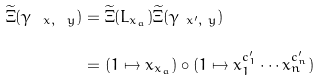Convert formula to latex. <formula><loc_0><loc_0><loc_500><loc_500>\widetilde { \Xi } ( \gamma _ { \ x , \ y } ) & = \widetilde { \Xi } ( L _ { x _ { a } } ) \widetilde { \Xi } ( \gamma _ { \ x ^ { \prime } , \ y } ) \\ & = ( 1 \mapsto x _ { x _ { a } } ) \circ ( 1 \mapsto x _ { 1 } ^ { c ^ { \prime } _ { 1 } } \cdots x _ { n } ^ { c ^ { \prime } _ { n } } )</formula> 